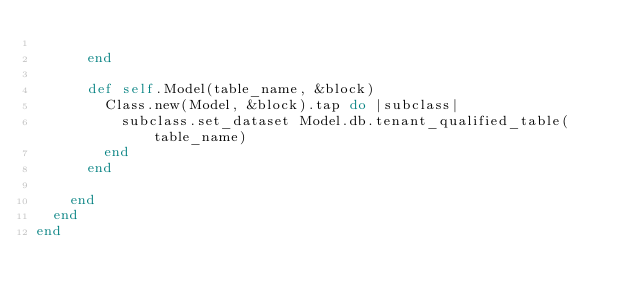Convert code to text. <code><loc_0><loc_0><loc_500><loc_500><_Ruby_>
      end

      def self.Model(table_name, &block)
        Class.new(Model, &block).tap do |subclass|
          subclass.set_dataset Model.db.tenant_qualified_table(table_name)
        end
      end

    end
  end
end</code> 